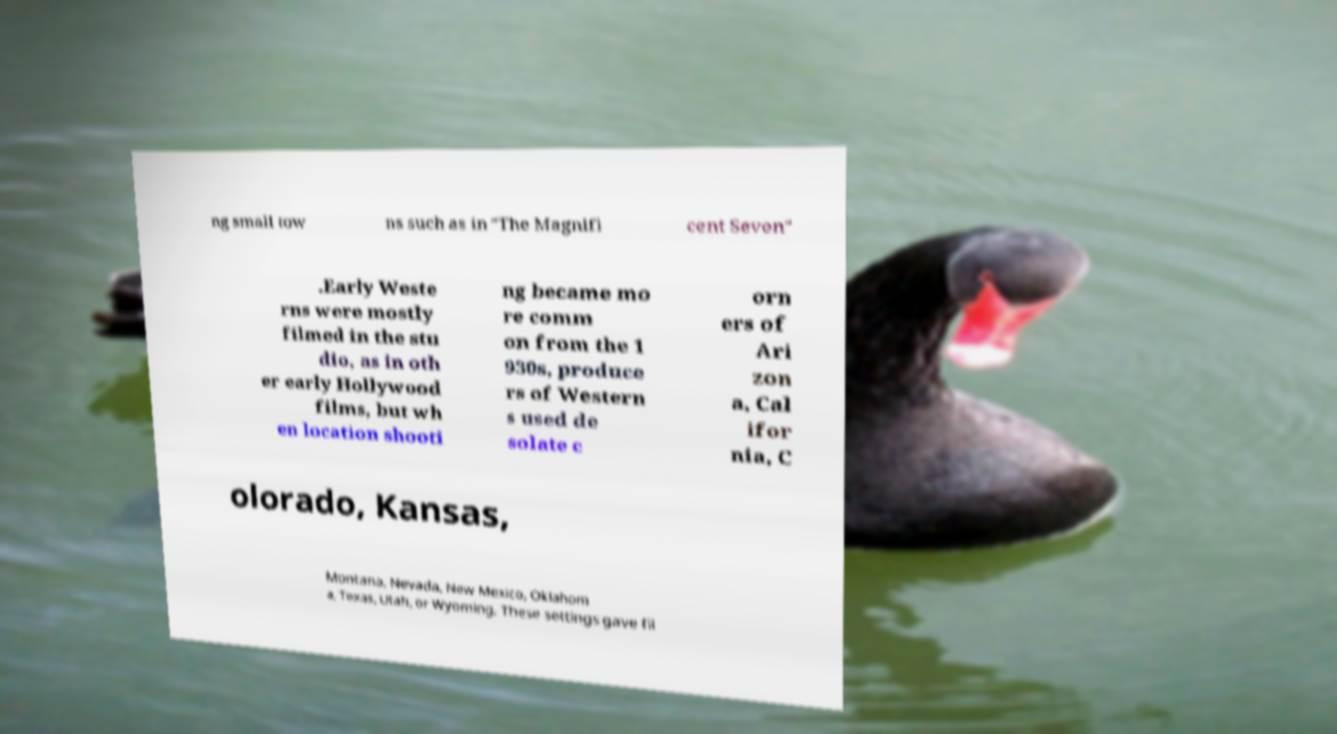Can you accurately transcribe the text from the provided image for me? ng small tow ns such as in "The Magnifi cent Seven" .Early Weste rns were mostly filmed in the stu dio, as in oth er early Hollywood films, but wh en location shooti ng became mo re comm on from the 1 930s, produce rs of Western s used de solate c orn ers of Ari zon a, Cal ifor nia, C olorado, Kansas, Montana, Nevada, New Mexico, Oklahom a, Texas, Utah, or Wyoming. These settings gave fil 